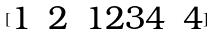<formula> <loc_0><loc_0><loc_500><loc_500>[ \begin{matrix} 1 & 2 & 1 2 3 4 & 4 \\ \end{matrix} ]</formula> 